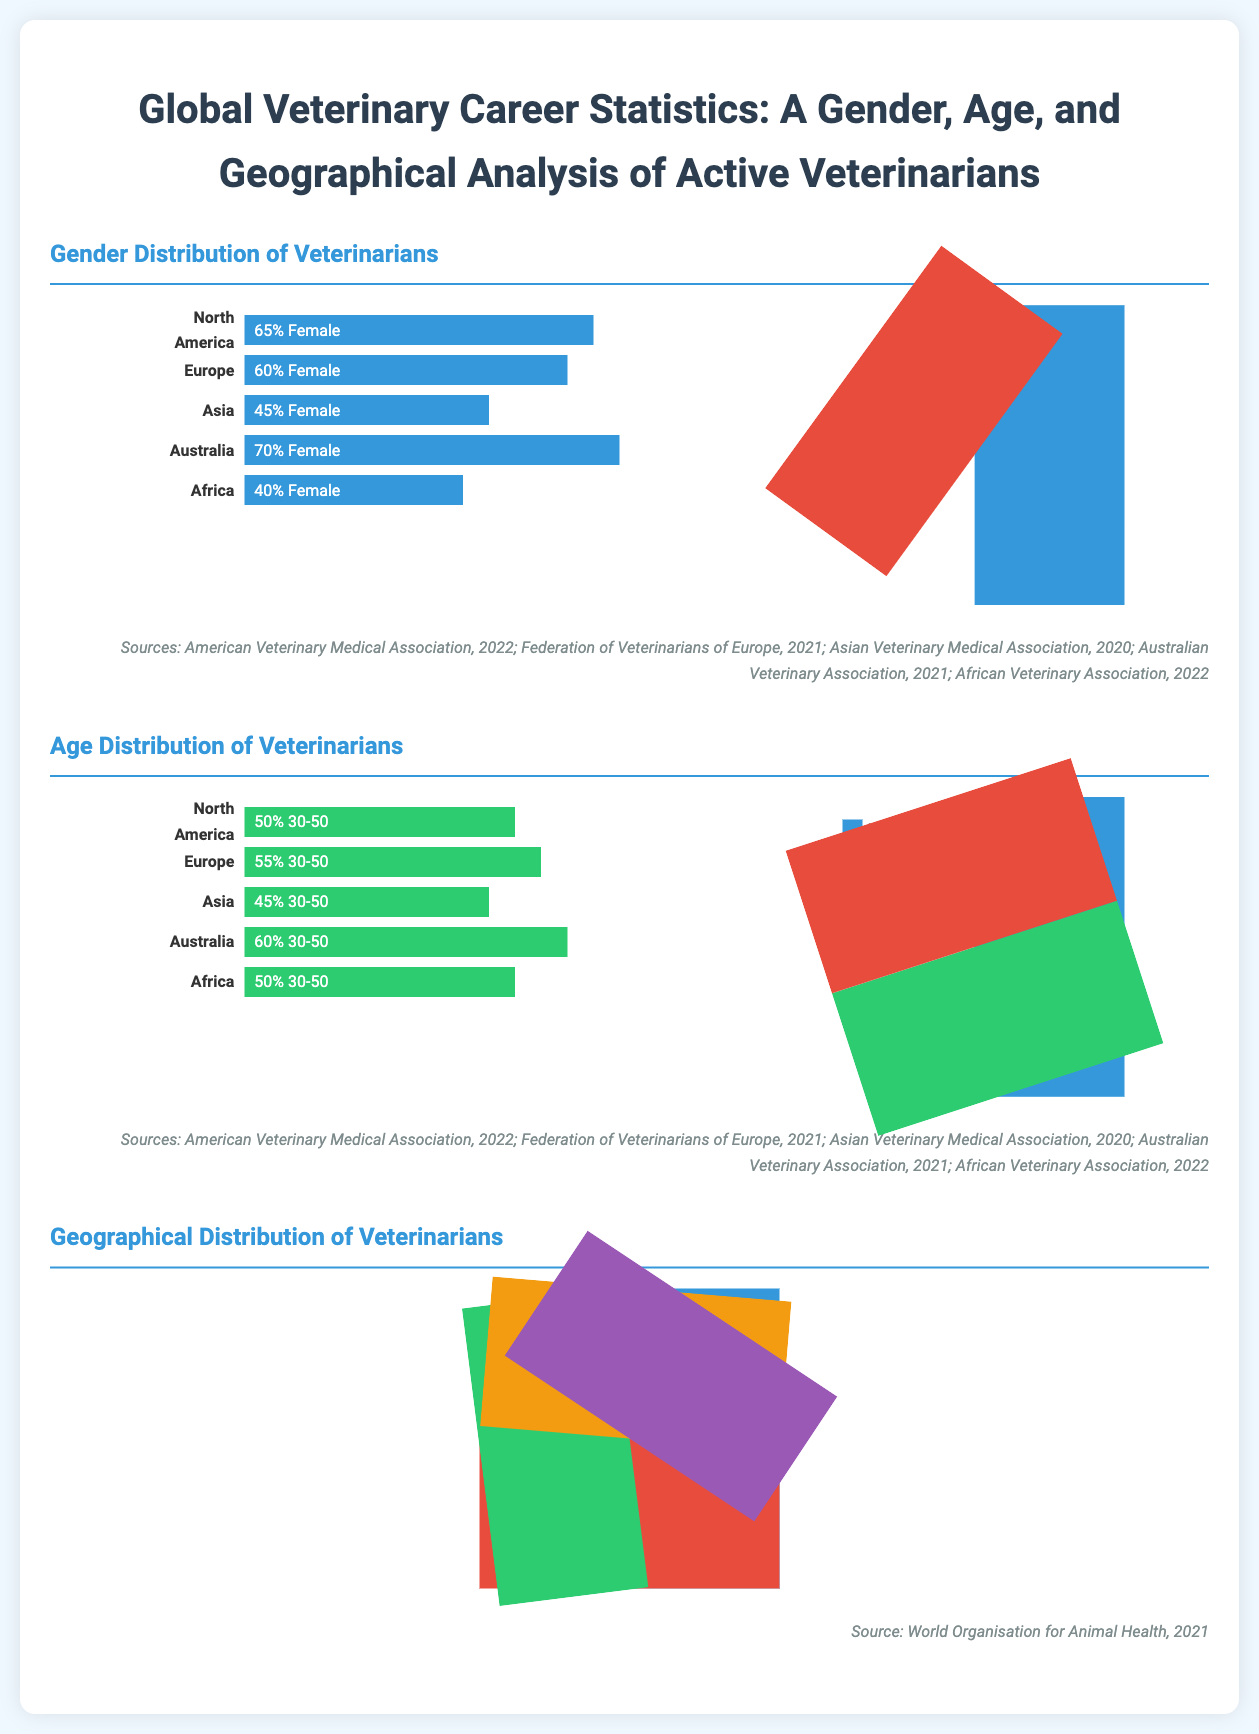What percentage of veterinarians in North America are female? The percentage of veterinarians in North America that are female is specified in the Gender Distribution section as 65%.
Answer: 65% Which continent has the highest percentage of female veterinarians? In the Gender Distribution section, Australia is noted to have the highest percentage of female veterinarians at 70%.
Answer: Australia What age group comprises 50% of veterinarians in North America? The Age Distribution section indicates that the age group 30-50 comprises 50% of veterinarians in North America.
Answer: 30-50 What is the geographical percentage of veterinarians in Europe? In the Geographical Distribution section, Europe is represented with 23% of veterinarians.
Answer: 23% What color represents "Under 30" in the pie chart? The pie chart in the Age Distribution section uses blue to represent the "Under 30" age group.
Answer: Blue Which region reports a female veterinarian percentage of 40%? According to the Gender Distribution section, Africa reports a female veterinarian percentage of 40%.
Answer: Africa What is the total percentage of veterinarians in Asia? The Geographical Distribution indicates Asia has 28% of veterinarians.
Answer: 28% Which organization provides data for the Age Distribution statistics? The sources listed for the Age Distribution are from the American Veterinary Medical Association, 2022.
Answer: American Veterinary Medical Association, 2022 